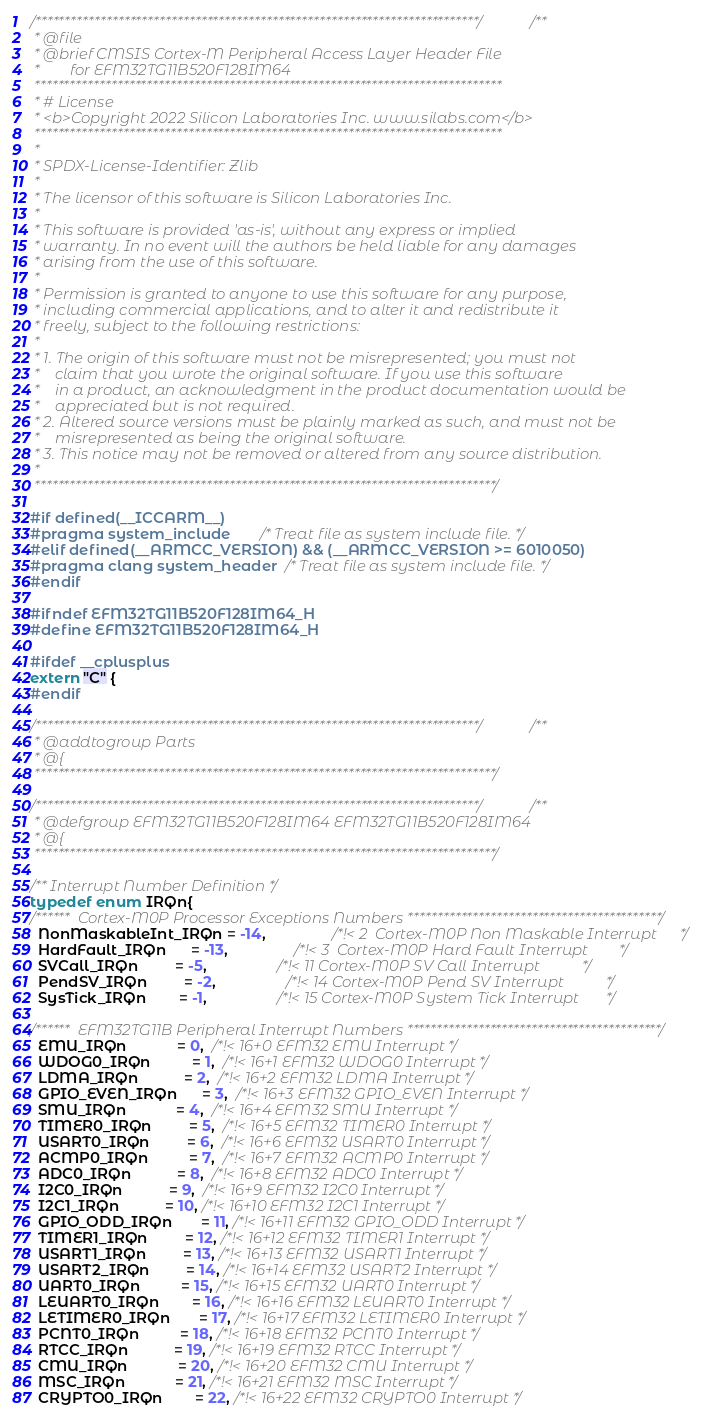<code> <loc_0><loc_0><loc_500><loc_500><_C_>/***************************************************************************//**
 * @file
 * @brief CMSIS Cortex-M Peripheral Access Layer Header File
 *        for EFM32TG11B520F128IM64
 *******************************************************************************
 * # License
 * <b>Copyright 2022 Silicon Laboratories Inc. www.silabs.com</b>
 *******************************************************************************
 *
 * SPDX-License-Identifier: Zlib
 *
 * The licensor of this software is Silicon Laboratories Inc.
 *
 * This software is provided 'as-is', without any express or implied
 * warranty. In no event will the authors be held liable for any damages
 * arising from the use of this software.
 *
 * Permission is granted to anyone to use this software for any purpose,
 * including commercial applications, and to alter it and redistribute it
 * freely, subject to the following restrictions:
 *
 * 1. The origin of this software must not be misrepresented; you must not
 *    claim that you wrote the original software. If you use this software
 *    in a product, an acknowledgment in the product documentation would be
 *    appreciated but is not required.
 * 2. Altered source versions must be plainly marked as such, and must not be
 *    misrepresented as being the original software.
 * 3. This notice may not be removed or altered from any source distribution.
 *
 ******************************************************************************/

#if defined(__ICCARM__)
#pragma system_include       /* Treat file as system include file. */
#elif defined(__ARMCC_VERSION) && (__ARMCC_VERSION >= 6010050)
#pragma clang system_header  /* Treat file as system include file. */
#endif

#ifndef EFM32TG11B520F128IM64_H
#define EFM32TG11B520F128IM64_H

#ifdef __cplusplus
extern "C" {
#endif

/***************************************************************************//**
 * @addtogroup Parts
 * @{
 ******************************************************************************/

/***************************************************************************//**
 * @defgroup EFM32TG11B520F128IM64 EFM32TG11B520F128IM64
 * @{
 ******************************************************************************/

/** Interrupt Number Definition */
typedef enum IRQn{
/******  Cortex-M0P Processor Exceptions Numbers *******************************************/
  NonMaskableInt_IRQn = -14,                /*!< 2  Cortex-M0P Non Maskable Interrupt      */
  HardFault_IRQn      = -13,                /*!< 3  Cortex-M0P Hard Fault Interrupt        */
  SVCall_IRQn         = -5,                 /*!< 11 Cortex-M0P SV Call Interrupt           */
  PendSV_IRQn         = -2,                 /*!< 14 Cortex-M0P Pend SV Interrupt           */
  SysTick_IRQn        = -1,                 /*!< 15 Cortex-M0P System Tick Interrupt       */

/******  EFM32TG11B Peripheral Interrupt Numbers *******************************************/
  EMU_IRQn            = 0,  /*!< 16+0 EFM32 EMU Interrupt */
  WDOG0_IRQn          = 1,  /*!< 16+1 EFM32 WDOG0 Interrupt */
  LDMA_IRQn           = 2,  /*!< 16+2 EFM32 LDMA Interrupt */
  GPIO_EVEN_IRQn      = 3,  /*!< 16+3 EFM32 GPIO_EVEN Interrupt */
  SMU_IRQn            = 4,  /*!< 16+4 EFM32 SMU Interrupt */
  TIMER0_IRQn         = 5,  /*!< 16+5 EFM32 TIMER0 Interrupt */
  USART0_IRQn         = 6,  /*!< 16+6 EFM32 USART0 Interrupt */
  ACMP0_IRQn          = 7,  /*!< 16+7 EFM32 ACMP0 Interrupt */
  ADC0_IRQn           = 8,  /*!< 16+8 EFM32 ADC0 Interrupt */
  I2C0_IRQn           = 9,  /*!< 16+9 EFM32 I2C0 Interrupt */
  I2C1_IRQn           = 10, /*!< 16+10 EFM32 I2C1 Interrupt */
  GPIO_ODD_IRQn       = 11, /*!< 16+11 EFM32 GPIO_ODD Interrupt */
  TIMER1_IRQn         = 12, /*!< 16+12 EFM32 TIMER1 Interrupt */
  USART1_IRQn         = 13, /*!< 16+13 EFM32 USART1 Interrupt */
  USART2_IRQn         = 14, /*!< 16+14 EFM32 USART2 Interrupt */
  UART0_IRQn          = 15, /*!< 16+15 EFM32 UART0 Interrupt */
  LEUART0_IRQn        = 16, /*!< 16+16 EFM32 LEUART0 Interrupt */
  LETIMER0_IRQn       = 17, /*!< 16+17 EFM32 LETIMER0 Interrupt */
  PCNT0_IRQn          = 18, /*!< 16+18 EFM32 PCNT0 Interrupt */
  RTCC_IRQn           = 19, /*!< 16+19 EFM32 RTCC Interrupt */
  CMU_IRQn            = 20, /*!< 16+20 EFM32 CMU Interrupt */
  MSC_IRQn            = 21, /*!< 16+21 EFM32 MSC Interrupt */
  CRYPTO0_IRQn        = 22, /*!< 16+22 EFM32 CRYPTO0 Interrupt */</code> 